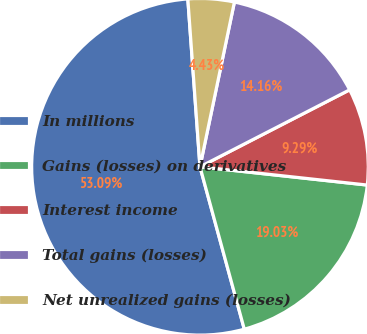Convert chart to OTSL. <chart><loc_0><loc_0><loc_500><loc_500><pie_chart><fcel>In millions<fcel>Gains (losses) on derivatives<fcel>Interest income<fcel>Total gains (losses)<fcel>Net unrealized gains (losses)<nl><fcel>53.09%<fcel>19.03%<fcel>9.29%<fcel>14.16%<fcel>4.43%<nl></chart> 